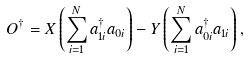<formula> <loc_0><loc_0><loc_500><loc_500>O ^ { \dagger } = X \left ( \sum _ { i = 1 } ^ { N } a ^ { \dagger } _ { 1 i } a _ { 0 i } \right ) - Y \left ( \sum _ { i = 1 } ^ { N } a ^ { \dagger } _ { 0 i } a _ { 1 i } \right ) ,</formula> 